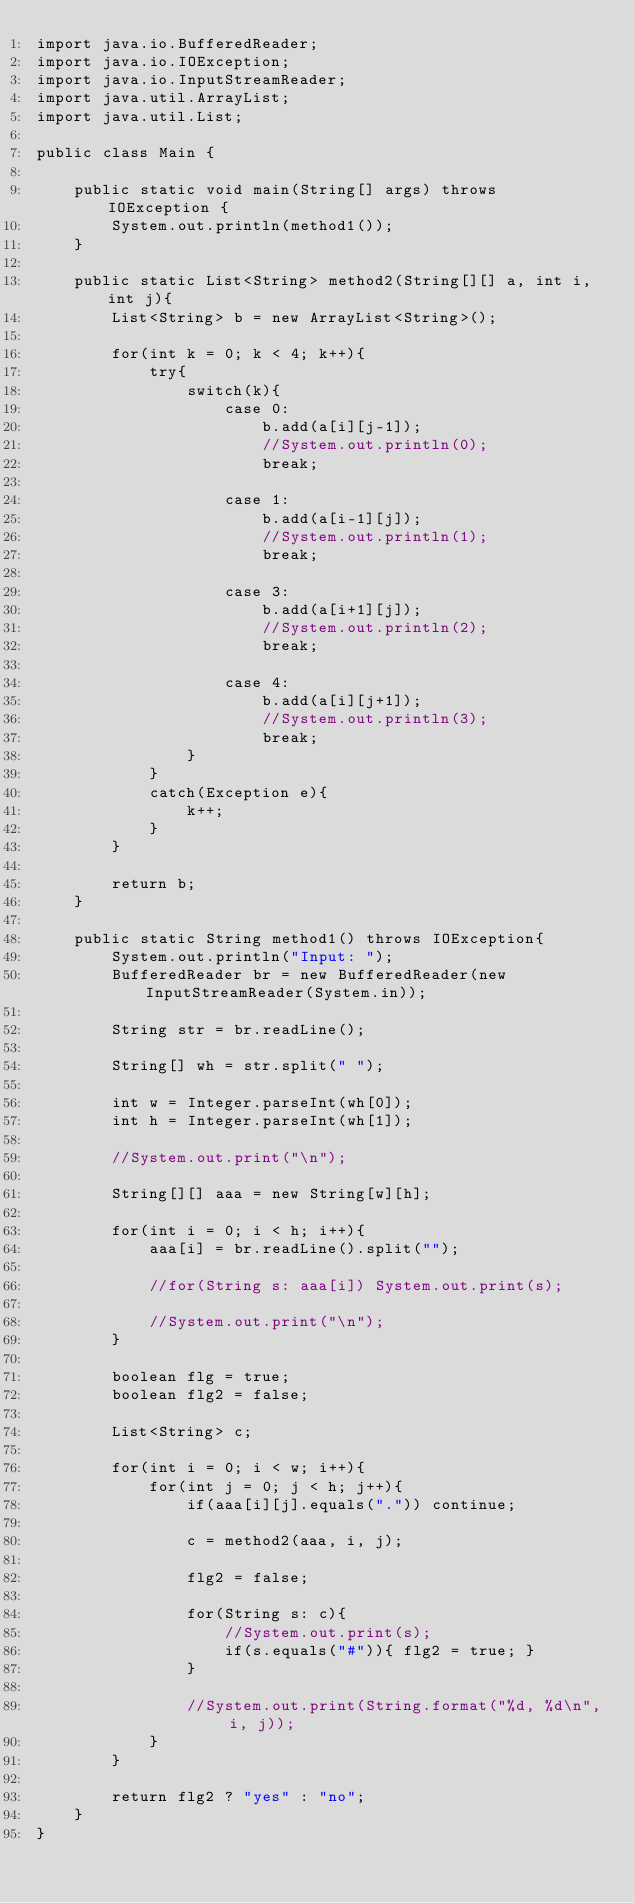<code> <loc_0><loc_0><loc_500><loc_500><_Java_>import java.io.BufferedReader;
import java.io.IOException;
import java.io.InputStreamReader;
import java.util.ArrayList;
import java.util.List;

public class Main {

	public static void main(String[] args) throws IOException {
		System.out.println(method1());
	}
	
	public static List<String> method2(String[][] a, int i, int j){
		List<String> b = new ArrayList<String>();
		
		for(int k = 0; k < 4; k++){
			try{
				switch(k){
					case 0:
						b.add(a[i][j-1]);
						//System.out.println(0);
						break;
						
					case 1:
						b.add(a[i-1][j]);
						//System.out.println(1);
						break;
						
					case 3:
						b.add(a[i+1][j]);
						//System.out.println(2);
						break;
						
					case 4:
						b.add(a[i][j+1]);
						//System.out.println(3);
						break;
				}
			}
			catch(Exception e){
				k++;
			}
		}
		
		return b;
	}
	
	public static String method1() throws IOException{
		System.out.println("Input: ");
		BufferedReader br = new BufferedReader(new InputStreamReader(System.in));
		
		String str = br.readLine();
		
		String[] wh = str.split(" ");
		
		int w = Integer.parseInt(wh[0]);
		int h = Integer.parseInt(wh[1]);
		
		//System.out.print("\n");
		
		String[][] aaa = new String[w][h];
		
		for(int i = 0; i < h; i++){
			aaa[i] = br.readLine().split("");
			
			//for(String s: aaa[i]) System.out.print(s);
			
			//System.out.print("\n");
		}
		
		boolean flg = true;
		boolean flg2 = false;
		
		List<String> c;
		
		for(int i = 0; i < w; i++){
			for(int j = 0; j < h; j++){
				if(aaa[i][j].equals(".")) continue;
				
				c = method2(aaa, i, j);
				
				flg2 = false;
				
				for(String s: c){
					//System.out.print(s);
					if(s.equals("#")){ flg2 = true; }
				}
				
				//System.out.print(String.format("%d, %d\n", i, j));
			}
		}
		
		return flg2 ? "yes" : "no";
	}
}
</code> 